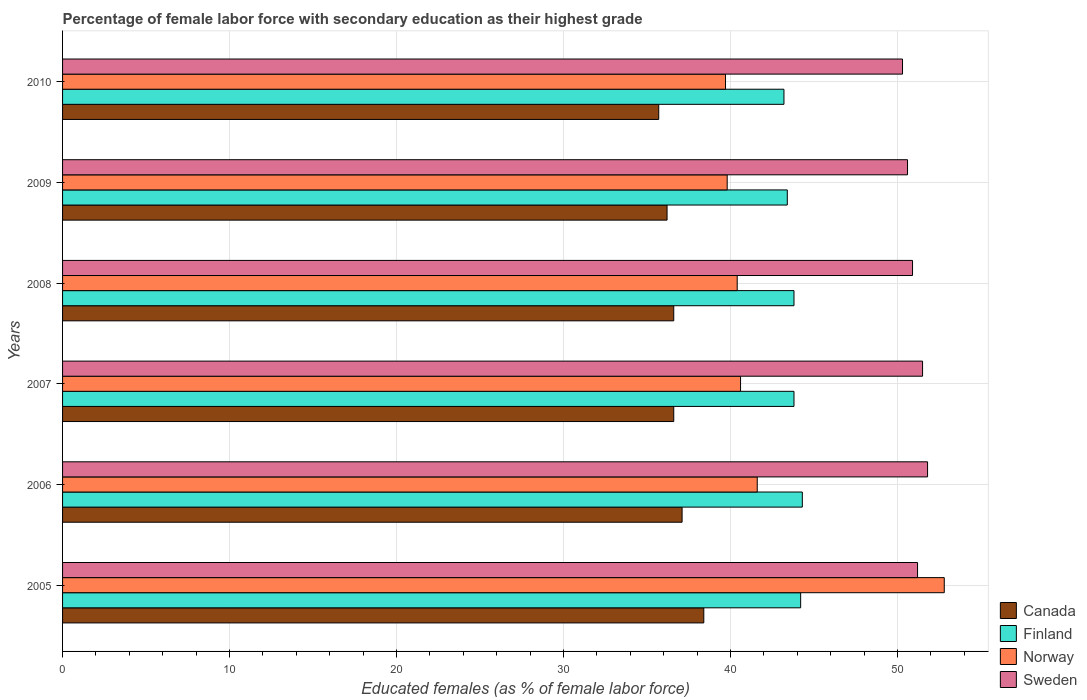What is the label of the 2nd group of bars from the top?
Give a very brief answer. 2009. In how many cases, is the number of bars for a given year not equal to the number of legend labels?
Offer a very short reply. 0. What is the percentage of female labor force with secondary education in Finland in 2009?
Your answer should be very brief. 43.4. Across all years, what is the maximum percentage of female labor force with secondary education in Finland?
Make the answer very short. 44.3. Across all years, what is the minimum percentage of female labor force with secondary education in Norway?
Your response must be concise. 39.7. In which year was the percentage of female labor force with secondary education in Canada maximum?
Make the answer very short. 2005. In which year was the percentage of female labor force with secondary education in Sweden minimum?
Give a very brief answer. 2010. What is the total percentage of female labor force with secondary education in Canada in the graph?
Your response must be concise. 220.6. What is the difference between the percentage of female labor force with secondary education in Sweden in 2008 and that in 2010?
Make the answer very short. 0.6. What is the difference between the percentage of female labor force with secondary education in Sweden in 2006 and the percentage of female labor force with secondary education in Norway in 2008?
Your answer should be very brief. 11.4. What is the average percentage of female labor force with secondary education in Canada per year?
Offer a terse response. 36.77. In the year 2006, what is the difference between the percentage of female labor force with secondary education in Canada and percentage of female labor force with secondary education in Finland?
Your answer should be compact. -7.2. What is the ratio of the percentage of female labor force with secondary education in Finland in 2006 to that in 2008?
Your answer should be very brief. 1.01. What is the difference between the highest and the second highest percentage of female labor force with secondary education in Canada?
Give a very brief answer. 1.3. What is the difference between the highest and the lowest percentage of female labor force with secondary education in Finland?
Your response must be concise. 1.1. In how many years, is the percentage of female labor force with secondary education in Sweden greater than the average percentage of female labor force with secondary education in Sweden taken over all years?
Ensure brevity in your answer.  3. Is the sum of the percentage of female labor force with secondary education in Canada in 2005 and 2006 greater than the maximum percentage of female labor force with secondary education in Finland across all years?
Provide a succinct answer. Yes. Is it the case that in every year, the sum of the percentage of female labor force with secondary education in Sweden and percentage of female labor force with secondary education in Finland is greater than the percentage of female labor force with secondary education in Norway?
Provide a short and direct response. Yes. How many bars are there?
Give a very brief answer. 24. How many years are there in the graph?
Your answer should be very brief. 6. What is the difference between two consecutive major ticks on the X-axis?
Your response must be concise. 10. Where does the legend appear in the graph?
Provide a short and direct response. Bottom right. How are the legend labels stacked?
Your answer should be compact. Vertical. What is the title of the graph?
Ensure brevity in your answer.  Percentage of female labor force with secondary education as their highest grade. Does "Burundi" appear as one of the legend labels in the graph?
Give a very brief answer. No. What is the label or title of the X-axis?
Make the answer very short. Educated females (as % of female labor force). What is the Educated females (as % of female labor force) of Canada in 2005?
Offer a terse response. 38.4. What is the Educated females (as % of female labor force) in Finland in 2005?
Offer a terse response. 44.2. What is the Educated females (as % of female labor force) in Norway in 2005?
Your response must be concise. 52.8. What is the Educated females (as % of female labor force) of Sweden in 2005?
Your answer should be compact. 51.2. What is the Educated females (as % of female labor force) in Canada in 2006?
Provide a succinct answer. 37.1. What is the Educated females (as % of female labor force) in Finland in 2006?
Offer a terse response. 44.3. What is the Educated females (as % of female labor force) of Norway in 2006?
Keep it short and to the point. 41.6. What is the Educated females (as % of female labor force) of Sweden in 2006?
Offer a terse response. 51.8. What is the Educated females (as % of female labor force) of Canada in 2007?
Your answer should be very brief. 36.6. What is the Educated females (as % of female labor force) in Finland in 2007?
Offer a very short reply. 43.8. What is the Educated females (as % of female labor force) in Norway in 2007?
Make the answer very short. 40.6. What is the Educated females (as % of female labor force) in Sweden in 2007?
Provide a succinct answer. 51.5. What is the Educated females (as % of female labor force) of Canada in 2008?
Offer a very short reply. 36.6. What is the Educated females (as % of female labor force) of Finland in 2008?
Offer a terse response. 43.8. What is the Educated females (as % of female labor force) of Norway in 2008?
Provide a succinct answer. 40.4. What is the Educated females (as % of female labor force) in Sweden in 2008?
Offer a terse response. 50.9. What is the Educated females (as % of female labor force) of Canada in 2009?
Your answer should be very brief. 36.2. What is the Educated females (as % of female labor force) in Finland in 2009?
Your answer should be compact. 43.4. What is the Educated females (as % of female labor force) in Norway in 2009?
Give a very brief answer. 39.8. What is the Educated females (as % of female labor force) of Sweden in 2009?
Ensure brevity in your answer.  50.6. What is the Educated females (as % of female labor force) in Canada in 2010?
Offer a terse response. 35.7. What is the Educated females (as % of female labor force) in Finland in 2010?
Ensure brevity in your answer.  43.2. What is the Educated females (as % of female labor force) in Norway in 2010?
Your answer should be compact. 39.7. What is the Educated females (as % of female labor force) of Sweden in 2010?
Your answer should be very brief. 50.3. Across all years, what is the maximum Educated females (as % of female labor force) in Canada?
Your response must be concise. 38.4. Across all years, what is the maximum Educated females (as % of female labor force) of Finland?
Your answer should be compact. 44.3. Across all years, what is the maximum Educated females (as % of female labor force) in Norway?
Provide a succinct answer. 52.8. Across all years, what is the maximum Educated females (as % of female labor force) of Sweden?
Provide a succinct answer. 51.8. Across all years, what is the minimum Educated females (as % of female labor force) of Canada?
Give a very brief answer. 35.7. Across all years, what is the minimum Educated females (as % of female labor force) of Finland?
Keep it short and to the point. 43.2. Across all years, what is the minimum Educated females (as % of female labor force) in Norway?
Offer a very short reply. 39.7. Across all years, what is the minimum Educated females (as % of female labor force) of Sweden?
Your answer should be very brief. 50.3. What is the total Educated females (as % of female labor force) in Canada in the graph?
Keep it short and to the point. 220.6. What is the total Educated females (as % of female labor force) of Finland in the graph?
Your answer should be very brief. 262.7. What is the total Educated females (as % of female labor force) in Norway in the graph?
Provide a succinct answer. 254.9. What is the total Educated females (as % of female labor force) of Sweden in the graph?
Provide a short and direct response. 306.3. What is the difference between the Educated females (as % of female labor force) in Finland in 2005 and that in 2006?
Keep it short and to the point. -0.1. What is the difference between the Educated females (as % of female labor force) of Sweden in 2005 and that in 2006?
Ensure brevity in your answer.  -0.6. What is the difference between the Educated females (as % of female labor force) in Canada in 2005 and that in 2007?
Ensure brevity in your answer.  1.8. What is the difference between the Educated females (as % of female labor force) of Finland in 2005 and that in 2007?
Your answer should be very brief. 0.4. What is the difference between the Educated females (as % of female labor force) in Finland in 2005 and that in 2008?
Offer a very short reply. 0.4. What is the difference between the Educated females (as % of female labor force) of Sweden in 2005 and that in 2008?
Give a very brief answer. 0.3. What is the difference between the Educated females (as % of female labor force) in Finland in 2005 and that in 2009?
Provide a short and direct response. 0.8. What is the difference between the Educated females (as % of female labor force) of Norway in 2005 and that in 2009?
Offer a terse response. 13. What is the difference between the Educated females (as % of female labor force) in Sweden in 2005 and that in 2009?
Provide a short and direct response. 0.6. What is the difference between the Educated females (as % of female labor force) of Sweden in 2005 and that in 2010?
Provide a succinct answer. 0.9. What is the difference between the Educated females (as % of female labor force) of Finland in 2006 and that in 2007?
Provide a succinct answer. 0.5. What is the difference between the Educated females (as % of female labor force) in Norway in 2006 and that in 2007?
Provide a succinct answer. 1. What is the difference between the Educated females (as % of female labor force) of Sweden in 2006 and that in 2007?
Your response must be concise. 0.3. What is the difference between the Educated females (as % of female labor force) in Canada in 2006 and that in 2008?
Offer a very short reply. 0.5. What is the difference between the Educated females (as % of female labor force) of Finland in 2006 and that in 2008?
Provide a short and direct response. 0.5. What is the difference between the Educated females (as % of female labor force) of Finland in 2006 and that in 2009?
Give a very brief answer. 0.9. What is the difference between the Educated females (as % of female labor force) in Norway in 2006 and that in 2009?
Your response must be concise. 1.8. What is the difference between the Educated females (as % of female labor force) in Canada in 2006 and that in 2010?
Ensure brevity in your answer.  1.4. What is the difference between the Educated females (as % of female labor force) of Finland in 2006 and that in 2010?
Give a very brief answer. 1.1. What is the difference between the Educated females (as % of female labor force) in Sweden in 2006 and that in 2010?
Your answer should be very brief. 1.5. What is the difference between the Educated females (as % of female labor force) in Finland in 2007 and that in 2008?
Give a very brief answer. 0. What is the difference between the Educated females (as % of female labor force) in Finland in 2007 and that in 2009?
Give a very brief answer. 0.4. What is the difference between the Educated females (as % of female labor force) in Sweden in 2007 and that in 2009?
Provide a succinct answer. 0.9. What is the difference between the Educated females (as % of female labor force) in Canada in 2007 and that in 2010?
Offer a very short reply. 0.9. What is the difference between the Educated females (as % of female labor force) in Norway in 2007 and that in 2010?
Give a very brief answer. 0.9. What is the difference between the Educated females (as % of female labor force) in Sweden in 2007 and that in 2010?
Provide a succinct answer. 1.2. What is the difference between the Educated females (as % of female labor force) in Norway in 2008 and that in 2009?
Give a very brief answer. 0.6. What is the difference between the Educated females (as % of female labor force) of Canada in 2008 and that in 2010?
Offer a very short reply. 0.9. What is the difference between the Educated females (as % of female labor force) of Norway in 2009 and that in 2010?
Your answer should be very brief. 0.1. What is the difference between the Educated females (as % of female labor force) of Canada in 2005 and the Educated females (as % of female labor force) of Finland in 2006?
Ensure brevity in your answer.  -5.9. What is the difference between the Educated females (as % of female labor force) of Finland in 2005 and the Educated females (as % of female labor force) of Norway in 2006?
Provide a short and direct response. 2.6. What is the difference between the Educated females (as % of female labor force) of Norway in 2005 and the Educated females (as % of female labor force) of Sweden in 2006?
Offer a terse response. 1. What is the difference between the Educated females (as % of female labor force) of Canada in 2005 and the Educated females (as % of female labor force) of Finland in 2007?
Your answer should be very brief. -5.4. What is the difference between the Educated females (as % of female labor force) of Canada in 2005 and the Educated females (as % of female labor force) of Norway in 2008?
Give a very brief answer. -2. What is the difference between the Educated females (as % of female labor force) in Canada in 2005 and the Educated females (as % of female labor force) in Sweden in 2008?
Keep it short and to the point. -12.5. What is the difference between the Educated females (as % of female labor force) in Finland in 2005 and the Educated females (as % of female labor force) in Sweden in 2008?
Offer a very short reply. -6.7. What is the difference between the Educated females (as % of female labor force) of Norway in 2005 and the Educated females (as % of female labor force) of Sweden in 2008?
Provide a succinct answer. 1.9. What is the difference between the Educated females (as % of female labor force) in Canada in 2005 and the Educated females (as % of female labor force) in Finland in 2009?
Ensure brevity in your answer.  -5. What is the difference between the Educated females (as % of female labor force) of Canada in 2005 and the Educated females (as % of female labor force) of Sweden in 2009?
Your answer should be compact. -12.2. What is the difference between the Educated females (as % of female labor force) of Finland in 2005 and the Educated females (as % of female labor force) of Norway in 2009?
Keep it short and to the point. 4.4. What is the difference between the Educated females (as % of female labor force) of Finland in 2005 and the Educated females (as % of female labor force) of Sweden in 2009?
Offer a terse response. -6.4. What is the difference between the Educated females (as % of female labor force) in Canada in 2005 and the Educated females (as % of female labor force) in Norway in 2010?
Offer a very short reply. -1.3. What is the difference between the Educated females (as % of female labor force) of Canada in 2006 and the Educated females (as % of female labor force) of Finland in 2007?
Provide a short and direct response. -6.7. What is the difference between the Educated females (as % of female labor force) of Canada in 2006 and the Educated females (as % of female labor force) of Norway in 2007?
Your answer should be very brief. -3.5. What is the difference between the Educated females (as % of female labor force) in Canada in 2006 and the Educated females (as % of female labor force) in Sweden in 2007?
Give a very brief answer. -14.4. What is the difference between the Educated females (as % of female labor force) in Finland in 2006 and the Educated females (as % of female labor force) in Norway in 2007?
Your response must be concise. 3.7. What is the difference between the Educated females (as % of female labor force) in Finland in 2006 and the Educated females (as % of female labor force) in Sweden in 2007?
Provide a succinct answer. -7.2. What is the difference between the Educated females (as % of female labor force) in Norway in 2006 and the Educated females (as % of female labor force) in Sweden in 2007?
Keep it short and to the point. -9.9. What is the difference between the Educated females (as % of female labor force) of Canada in 2006 and the Educated females (as % of female labor force) of Sweden in 2008?
Make the answer very short. -13.8. What is the difference between the Educated females (as % of female labor force) of Finland in 2006 and the Educated females (as % of female labor force) of Norway in 2008?
Make the answer very short. 3.9. What is the difference between the Educated females (as % of female labor force) in Finland in 2006 and the Educated females (as % of female labor force) in Sweden in 2008?
Make the answer very short. -6.6. What is the difference between the Educated females (as % of female labor force) of Norway in 2006 and the Educated females (as % of female labor force) of Sweden in 2008?
Ensure brevity in your answer.  -9.3. What is the difference between the Educated females (as % of female labor force) of Canada in 2006 and the Educated females (as % of female labor force) of Finland in 2009?
Keep it short and to the point. -6.3. What is the difference between the Educated females (as % of female labor force) of Canada in 2006 and the Educated females (as % of female labor force) of Norway in 2009?
Give a very brief answer. -2.7. What is the difference between the Educated females (as % of female labor force) of Canada in 2006 and the Educated females (as % of female labor force) of Sweden in 2009?
Give a very brief answer. -13.5. What is the difference between the Educated females (as % of female labor force) in Finland in 2006 and the Educated females (as % of female labor force) in Sweden in 2009?
Keep it short and to the point. -6.3. What is the difference between the Educated females (as % of female labor force) of Canada in 2006 and the Educated females (as % of female labor force) of Norway in 2010?
Your response must be concise. -2.6. What is the difference between the Educated females (as % of female labor force) of Canada in 2006 and the Educated females (as % of female labor force) of Sweden in 2010?
Offer a terse response. -13.2. What is the difference between the Educated females (as % of female labor force) in Canada in 2007 and the Educated females (as % of female labor force) in Finland in 2008?
Offer a terse response. -7.2. What is the difference between the Educated females (as % of female labor force) of Canada in 2007 and the Educated females (as % of female labor force) of Sweden in 2008?
Your answer should be very brief. -14.3. What is the difference between the Educated females (as % of female labor force) of Finland in 2007 and the Educated females (as % of female labor force) of Sweden in 2008?
Keep it short and to the point. -7.1. What is the difference between the Educated females (as % of female labor force) in Norway in 2007 and the Educated females (as % of female labor force) in Sweden in 2008?
Ensure brevity in your answer.  -10.3. What is the difference between the Educated females (as % of female labor force) of Canada in 2007 and the Educated females (as % of female labor force) of Norway in 2009?
Offer a terse response. -3.2. What is the difference between the Educated females (as % of female labor force) in Finland in 2007 and the Educated females (as % of female labor force) in Sweden in 2009?
Your answer should be compact. -6.8. What is the difference between the Educated females (as % of female labor force) in Norway in 2007 and the Educated females (as % of female labor force) in Sweden in 2009?
Offer a very short reply. -10. What is the difference between the Educated females (as % of female labor force) in Canada in 2007 and the Educated females (as % of female labor force) in Norway in 2010?
Provide a short and direct response. -3.1. What is the difference between the Educated females (as % of female labor force) in Canada in 2007 and the Educated females (as % of female labor force) in Sweden in 2010?
Provide a short and direct response. -13.7. What is the difference between the Educated females (as % of female labor force) of Finland in 2007 and the Educated females (as % of female labor force) of Norway in 2010?
Keep it short and to the point. 4.1. What is the difference between the Educated females (as % of female labor force) in Finland in 2007 and the Educated females (as % of female labor force) in Sweden in 2010?
Offer a terse response. -6.5. What is the difference between the Educated females (as % of female labor force) in Norway in 2007 and the Educated females (as % of female labor force) in Sweden in 2010?
Give a very brief answer. -9.7. What is the difference between the Educated females (as % of female labor force) of Canada in 2008 and the Educated females (as % of female labor force) of Finland in 2009?
Keep it short and to the point. -6.8. What is the difference between the Educated females (as % of female labor force) in Canada in 2008 and the Educated females (as % of female labor force) in Finland in 2010?
Provide a short and direct response. -6.6. What is the difference between the Educated females (as % of female labor force) in Canada in 2008 and the Educated females (as % of female labor force) in Sweden in 2010?
Ensure brevity in your answer.  -13.7. What is the difference between the Educated females (as % of female labor force) of Finland in 2008 and the Educated females (as % of female labor force) of Norway in 2010?
Offer a terse response. 4.1. What is the difference between the Educated females (as % of female labor force) of Finland in 2008 and the Educated females (as % of female labor force) of Sweden in 2010?
Provide a short and direct response. -6.5. What is the difference between the Educated females (as % of female labor force) in Canada in 2009 and the Educated females (as % of female labor force) in Finland in 2010?
Provide a succinct answer. -7. What is the difference between the Educated females (as % of female labor force) in Canada in 2009 and the Educated females (as % of female labor force) in Norway in 2010?
Provide a succinct answer. -3.5. What is the difference between the Educated females (as % of female labor force) of Canada in 2009 and the Educated females (as % of female labor force) of Sweden in 2010?
Provide a short and direct response. -14.1. What is the difference between the Educated females (as % of female labor force) of Finland in 2009 and the Educated females (as % of female labor force) of Sweden in 2010?
Make the answer very short. -6.9. What is the difference between the Educated females (as % of female labor force) of Norway in 2009 and the Educated females (as % of female labor force) of Sweden in 2010?
Your answer should be compact. -10.5. What is the average Educated females (as % of female labor force) of Canada per year?
Ensure brevity in your answer.  36.77. What is the average Educated females (as % of female labor force) of Finland per year?
Provide a succinct answer. 43.78. What is the average Educated females (as % of female labor force) of Norway per year?
Your response must be concise. 42.48. What is the average Educated females (as % of female labor force) in Sweden per year?
Provide a succinct answer. 51.05. In the year 2005, what is the difference between the Educated females (as % of female labor force) in Canada and Educated females (as % of female labor force) in Norway?
Keep it short and to the point. -14.4. In the year 2005, what is the difference between the Educated females (as % of female labor force) in Canada and Educated females (as % of female labor force) in Sweden?
Make the answer very short. -12.8. In the year 2005, what is the difference between the Educated females (as % of female labor force) of Finland and Educated females (as % of female labor force) of Norway?
Your answer should be compact. -8.6. In the year 2005, what is the difference between the Educated females (as % of female labor force) in Norway and Educated females (as % of female labor force) in Sweden?
Make the answer very short. 1.6. In the year 2006, what is the difference between the Educated females (as % of female labor force) of Canada and Educated females (as % of female labor force) of Sweden?
Ensure brevity in your answer.  -14.7. In the year 2006, what is the difference between the Educated females (as % of female labor force) of Finland and Educated females (as % of female labor force) of Norway?
Make the answer very short. 2.7. In the year 2006, what is the difference between the Educated females (as % of female labor force) of Finland and Educated females (as % of female labor force) of Sweden?
Your response must be concise. -7.5. In the year 2006, what is the difference between the Educated females (as % of female labor force) in Norway and Educated females (as % of female labor force) in Sweden?
Keep it short and to the point. -10.2. In the year 2007, what is the difference between the Educated females (as % of female labor force) of Canada and Educated females (as % of female labor force) of Norway?
Provide a succinct answer. -4. In the year 2007, what is the difference between the Educated females (as % of female labor force) of Canada and Educated females (as % of female labor force) of Sweden?
Provide a succinct answer. -14.9. In the year 2007, what is the difference between the Educated females (as % of female labor force) in Finland and Educated females (as % of female labor force) in Norway?
Offer a very short reply. 3.2. In the year 2007, what is the difference between the Educated females (as % of female labor force) of Norway and Educated females (as % of female labor force) of Sweden?
Give a very brief answer. -10.9. In the year 2008, what is the difference between the Educated females (as % of female labor force) of Canada and Educated females (as % of female labor force) of Sweden?
Provide a succinct answer. -14.3. In the year 2008, what is the difference between the Educated females (as % of female labor force) in Finland and Educated females (as % of female labor force) in Norway?
Your answer should be very brief. 3.4. In the year 2008, what is the difference between the Educated females (as % of female labor force) of Finland and Educated females (as % of female labor force) of Sweden?
Provide a succinct answer. -7.1. In the year 2009, what is the difference between the Educated females (as % of female labor force) in Canada and Educated females (as % of female labor force) in Finland?
Provide a succinct answer. -7.2. In the year 2009, what is the difference between the Educated females (as % of female labor force) in Canada and Educated females (as % of female labor force) in Norway?
Offer a very short reply. -3.6. In the year 2009, what is the difference between the Educated females (as % of female labor force) of Canada and Educated females (as % of female labor force) of Sweden?
Your answer should be compact. -14.4. In the year 2009, what is the difference between the Educated females (as % of female labor force) in Norway and Educated females (as % of female labor force) in Sweden?
Make the answer very short. -10.8. In the year 2010, what is the difference between the Educated females (as % of female labor force) of Canada and Educated females (as % of female labor force) of Norway?
Your response must be concise. -4. In the year 2010, what is the difference between the Educated females (as % of female labor force) in Canada and Educated females (as % of female labor force) in Sweden?
Your answer should be very brief. -14.6. In the year 2010, what is the difference between the Educated females (as % of female labor force) in Finland and Educated females (as % of female labor force) in Norway?
Give a very brief answer. 3.5. What is the ratio of the Educated females (as % of female labor force) in Canada in 2005 to that in 2006?
Ensure brevity in your answer.  1.03. What is the ratio of the Educated females (as % of female labor force) in Finland in 2005 to that in 2006?
Give a very brief answer. 1. What is the ratio of the Educated females (as % of female labor force) of Norway in 2005 to that in 2006?
Provide a succinct answer. 1.27. What is the ratio of the Educated females (as % of female labor force) of Sweden in 2005 to that in 2006?
Offer a very short reply. 0.99. What is the ratio of the Educated females (as % of female labor force) of Canada in 2005 to that in 2007?
Provide a succinct answer. 1.05. What is the ratio of the Educated females (as % of female labor force) in Finland in 2005 to that in 2007?
Your response must be concise. 1.01. What is the ratio of the Educated females (as % of female labor force) of Norway in 2005 to that in 2007?
Ensure brevity in your answer.  1.3. What is the ratio of the Educated females (as % of female labor force) in Canada in 2005 to that in 2008?
Keep it short and to the point. 1.05. What is the ratio of the Educated females (as % of female labor force) in Finland in 2005 to that in 2008?
Provide a short and direct response. 1.01. What is the ratio of the Educated females (as % of female labor force) in Norway in 2005 to that in 2008?
Keep it short and to the point. 1.31. What is the ratio of the Educated females (as % of female labor force) in Sweden in 2005 to that in 2008?
Give a very brief answer. 1.01. What is the ratio of the Educated females (as % of female labor force) in Canada in 2005 to that in 2009?
Offer a very short reply. 1.06. What is the ratio of the Educated females (as % of female labor force) in Finland in 2005 to that in 2009?
Your response must be concise. 1.02. What is the ratio of the Educated females (as % of female labor force) of Norway in 2005 to that in 2009?
Offer a terse response. 1.33. What is the ratio of the Educated females (as % of female labor force) of Sweden in 2005 to that in 2009?
Your answer should be very brief. 1.01. What is the ratio of the Educated females (as % of female labor force) in Canada in 2005 to that in 2010?
Make the answer very short. 1.08. What is the ratio of the Educated females (as % of female labor force) of Finland in 2005 to that in 2010?
Offer a terse response. 1.02. What is the ratio of the Educated females (as % of female labor force) of Norway in 2005 to that in 2010?
Provide a succinct answer. 1.33. What is the ratio of the Educated females (as % of female labor force) in Sweden in 2005 to that in 2010?
Give a very brief answer. 1.02. What is the ratio of the Educated females (as % of female labor force) in Canada in 2006 to that in 2007?
Give a very brief answer. 1.01. What is the ratio of the Educated females (as % of female labor force) in Finland in 2006 to that in 2007?
Your response must be concise. 1.01. What is the ratio of the Educated females (as % of female labor force) in Norway in 2006 to that in 2007?
Offer a very short reply. 1.02. What is the ratio of the Educated females (as % of female labor force) of Canada in 2006 to that in 2008?
Offer a very short reply. 1.01. What is the ratio of the Educated females (as % of female labor force) of Finland in 2006 to that in 2008?
Give a very brief answer. 1.01. What is the ratio of the Educated females (as % of female labor force) in Norway in 2006 to that in 2008?
Your answer should be very brief. 1.03. What is the ratio of the Educated females (as % of female labor force) of Sweden in 2006 to that in 2008?
Your answer should be very brief. 1.02. What is the ratio of the Educated females (as % of female labor force) in Canada in 2006 to that in 2009?
Provide a short and direct response. 1.02. What is the ratio of the Educated females (as % of female labor force) in Finland in 2006 to that in 2009?
Your answer should be very brief. 1.02. What is the ratio of the Educated females (as % of female labor force) of Norway in 2006 to that in 2009?
Give a very brief answer. 1.05. What is the ratio of the Educated females (as % of female labor force) of Sweden in 2006 to that in 2009?
Make the answer very short. 1.02. What is the ratio of the Educated females (as % of female labor force) of Canada in 2006 to that in 2010?
Your response must be concise. 1.04. What is the ratio of the Educated females (as % of female labor force) in Finland in 2006 to that in 2010?
Your answer should be compact. 1.03. What is the ratio of the Educated females (as % of female labor force) of Norway in 2006 to that in 2010?
Make the answer very short. 1.05. What is the ratio of the Educated females (as % of female labor force) in Sweden in 2006 to that in 2010?
Make the answer very short. 1.03. What is the ratio of the Educated females (as % of female labor force) of Canada in 2007 to that in 2008?
Keep it short and to the point. 1. What is the ratio of the Educated females (as % of female labor force) in Finland in 2007 to that in 2008?
Offer a very short reply. 1. What is the ratio of the Educated females (as % of female labor force) of Sweden in 2007 to that in 2008?
Your response must be concise. 1.01. What is the ratio of the Educated females (as % of female labor force) of Finland in 2007 to that in 2009?
Your response must be concise. 1.01. What is the ratio of the Educated females (as % of female labor force) of Norway in 2007 to that in 2009?
Provide a short and direct response. 1.02. What is the ratio of the Educated females (as % of female labor force) of Sweden in 2007 to that in 2009?
Provide a succinct answer. 1.02. What is the ratio of the Educated females (as % of female labor force) of Canada in 2007 to that in 2010?
Provide a succinct answer. 1.03. What is the ratio of the Educated females (as % of female labor force) in Finland in 2007 to that in 2010?
Provide a short and direct response. 1.01. What is the ratio of the Educated females (as % of female labor force) of Norway in 2007 to that in 2010?
Keep it short and to the point. 1.02. What is the ratio of the Educated females (as % of female labor force) of Sweden in 2007 to that in 2010?
Make the answer very short. 1.02. What is the ratio of the Educated females (as % of female labor force) of Canada in 2008 to that in 2009?
Make the answer very short. 1.01. What is the ratio of the Educated females (as % of female labor force) in Finland in 2008 to that in 2009?
Provide a short and direct response. 1.01. What is the ratio of the Educated females (as % of female labor force) of Norway in 2008 to that in 2009?
Offer a terse response. 1.02. What is the ratio of the Educated females (as % of female labor force) of Sweden in 2008 to that in 2009?
Offer a very short reply. 1.01. What is the ratio of the Educated females (as % of female labor force) in Canada in 2008 to that in 2010?
Your answer should be compact. 1.03. What is the ratio of the Educated females (as % of female labor force) in Finland in 2008 to that in 2010?
Ensure brevity in your answer.  1.01. What is the ratio of the Educated females (as % of female labor force) in Norway in 2008 to that in 2010?
Your answer should be very brief. 1.02. What is the ratio of the Educated females (as % of female labor force) in Sweden in 2008 to that in 2010?
Keep it short and to the point. 1.01. What is the ratio of the Educated females (as % of female labor force) in Canada in 2009 to that in 2010?
Ensure brevity in your answer.  1.01. What is the ratio of the Educated females (as % of female labor force) of Norway in 2009 to that in 2010?
Keep it short and to the point. 1. What is the difference between the highest and the second highest Educated females (as % of female labor force) in Sweden?
Keep it short and to the point. 0.3. What is the difference between the highest and the lowest Educated females (as % of female labor force) in Finland?
Offer a terse response. 1.1. What is the difference between the highest and the lowest Educated females (as % of female labor force) in Sweden?
Offer a very short reply. 1.5. 